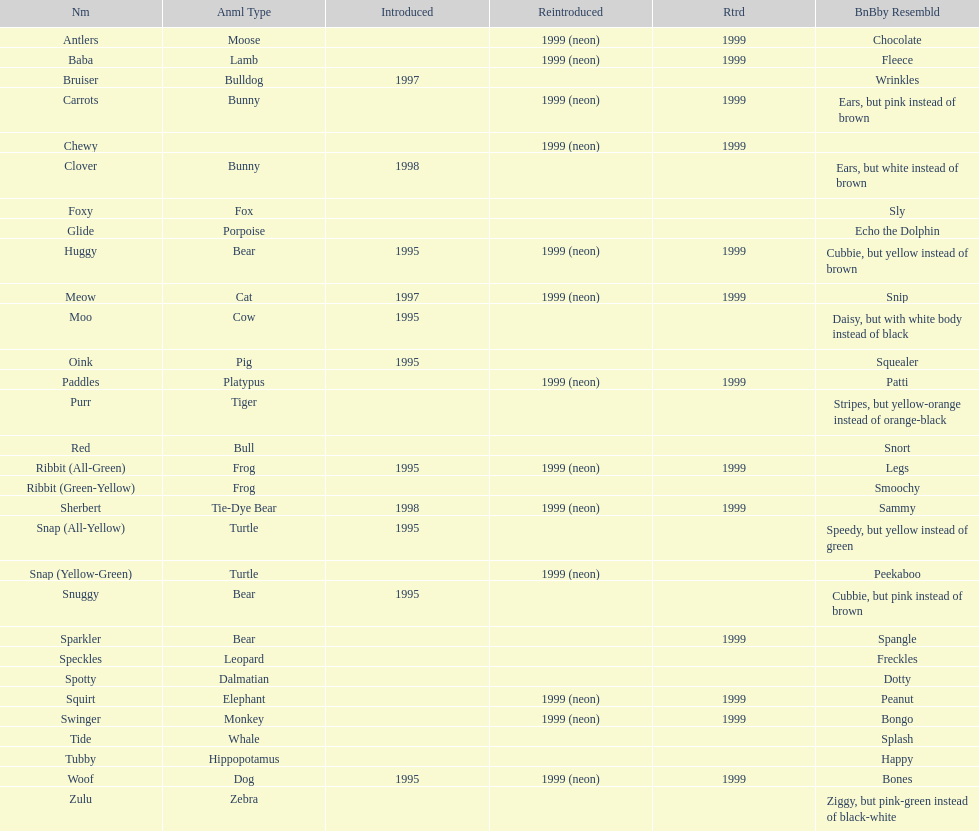Which animal type has the most pillow pals? Bear. 